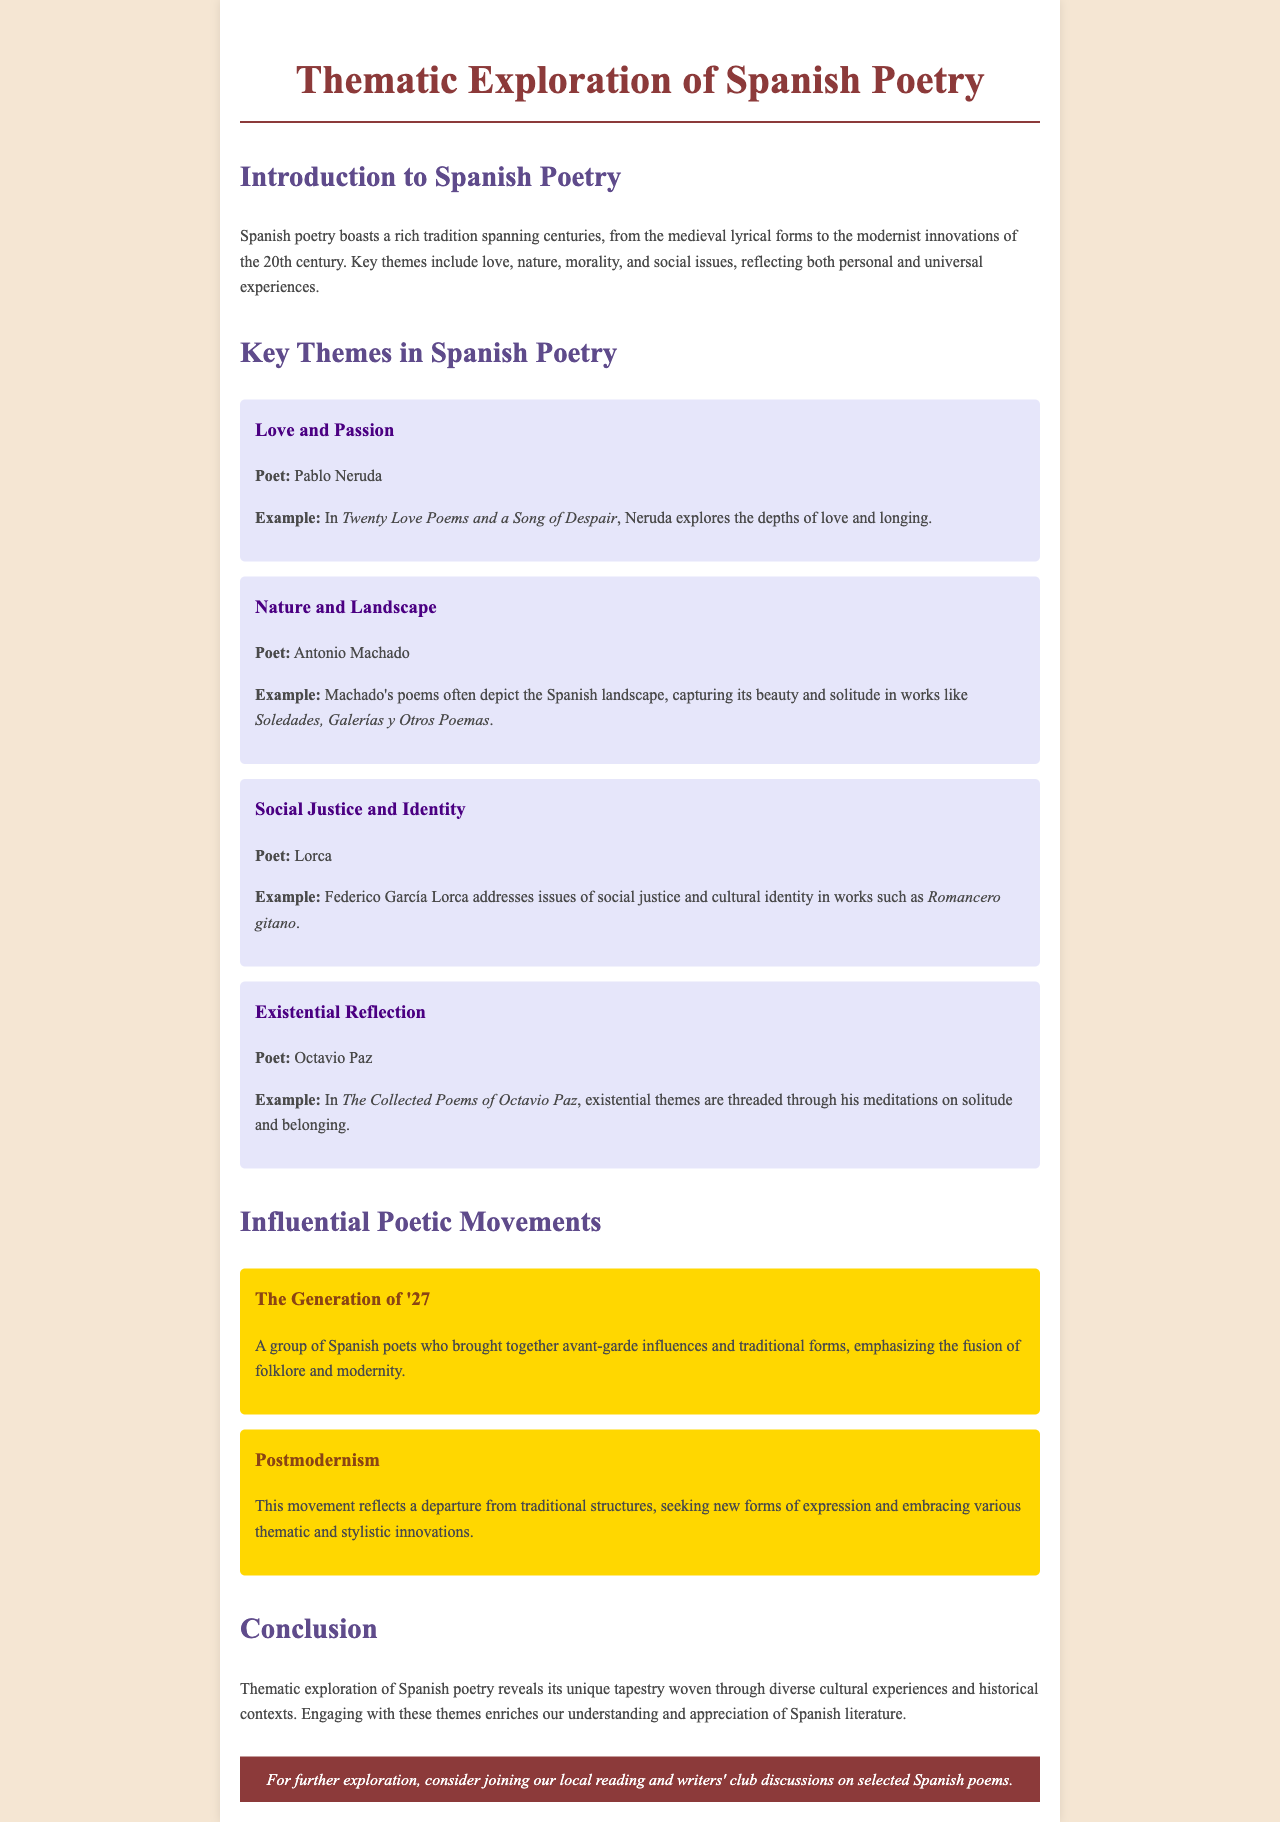What is the title of the document? The title of the document is stated in the header as "Thematic Exploration of Spanish Poetry."
Answer: Thematic Exploration of Spanish Poetry Who is the poet associated with the theme of Love and Passion? The poet mentioned for the theme of Love and Passion is provided in the document.
Answer: Pablo Neruda What does Antonio Machado often depict in his poems? The document specifies that Machado captures the beauty and solitude of the Spanish landscape.
Answer: Spanish landscape Which poetic movement emphasized the fusion of folklore and modernity? This information is found in the section describing a specific poetic movement.
Answer: The Generation of '27 What is one existential theme explored by Octavio Paz? The document mentions that Paz's poems address themes of solitude and belonging.
Answer: Solitude How many key themes are outlined in the document? You can find the total number in the section describing key themes.
Answer: Four What is the example work mentioned for the theme of Social Justice and Identity? The work provided in the document is specifically linked to a poet and their thematic exploration.
Answer: Romancero gitano What background context does the introduction provide about Spanish poetry? The introduction discusses the tradition of Spanish poetry and its key themes.
Answer: Rich tradition What does the footer suggest for further exploration? The footer provides an action for readers who want to engage further with the topic presented.
Answer: Joining local reading and writers' club discussions 